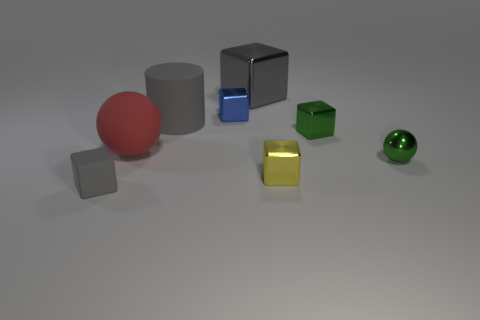There is a large gray thing that is in front of the blue object; what is its shape?
Give a very brief answer. Cylinder. There is a green object that is the same size as the metallic ball; what material is it?
Keep it short and to the point. Metal. What number of objects are either cubes that are in front of the green metal block or matte things that are behind the small yellow metal cube?
Give a very brief answer. 4. What is the size of the blue block that is the same material as the yellow block?
Provide a succinct answer. Small. What number of rubber things are small gray things or green cylinders?
Offer a very short reply. 1. How big is the gray matte block?
Make the answer very short. Small. Do the cylinder and the green metallic sphere have the same size?
Offer a terse response. No. What material is the cube in front of the yellow object?
Your answer should be compact. Rubber. What is the material of the tiny gray thing that is the same shape as the small blue metal thing?
Your answer should be compact. Rubber. Is there a object that is in front of the tiny object that is behind the big cylinder?
Your answer should be very brief. Yes. 